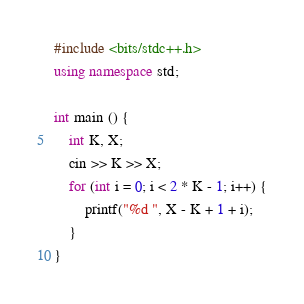Convert code to text. <code><loc_0><loc_0><loc_500><loc_500><_C++_>#include <bits/stdc++.h>
using namespace std;

int main () {
    int K, X;
    cin >> K >> X;
    for (int i = 0; i < 2 * K - 1; i++) {
        printf("%d ", X - K + 1 + i);
    }
}</code> 